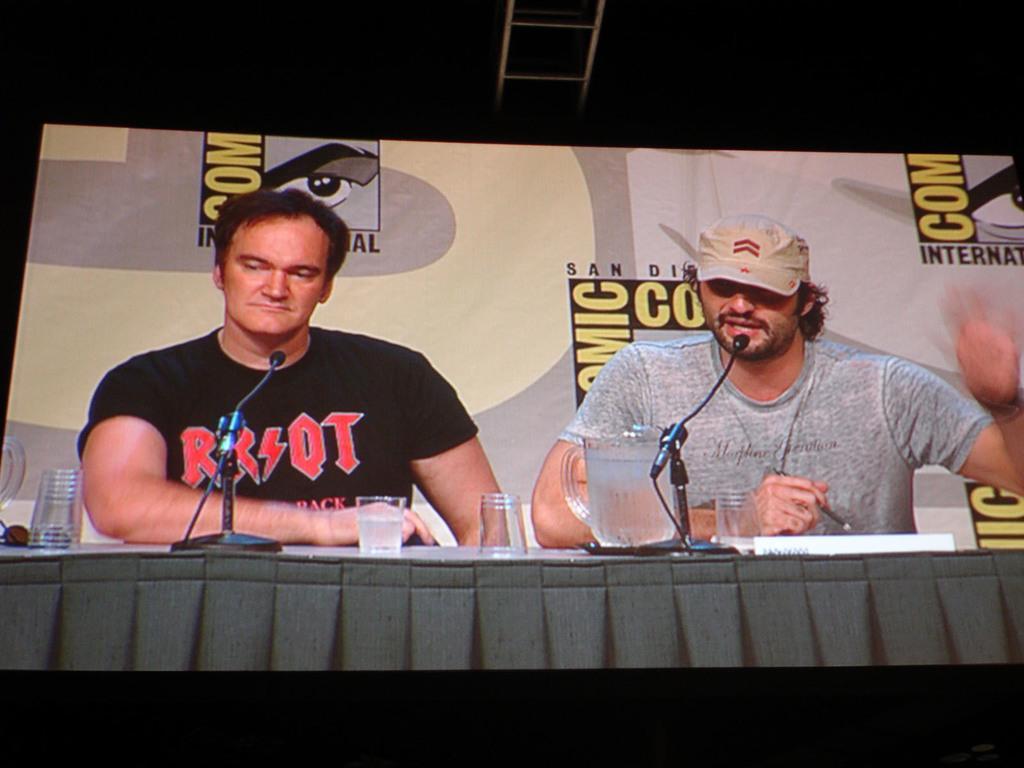In one or two sentences, can you explain what this image depicts? In the center of this picture there is a table on the top of which a jug of water, glasses, papers, microphones attached to the stand and some other items are placed and we can see the two persons wearing t-shirts and sitting. In the background there is a banner on the top of which we can see the text and the pictures. At the top we can see the metal rods. 